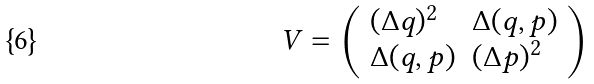Convert formula to latex. <formula><loc_0><loc_0><loc_500><loc_500>V = \left ( \begin{array} { l l } ( \Delta q ) ^ { 2 } & \Delta ( q , p ) \\ \Delta ( q , p ) & ( \Delta p ) ^ { 2 } \end{array} \right )</formula> 